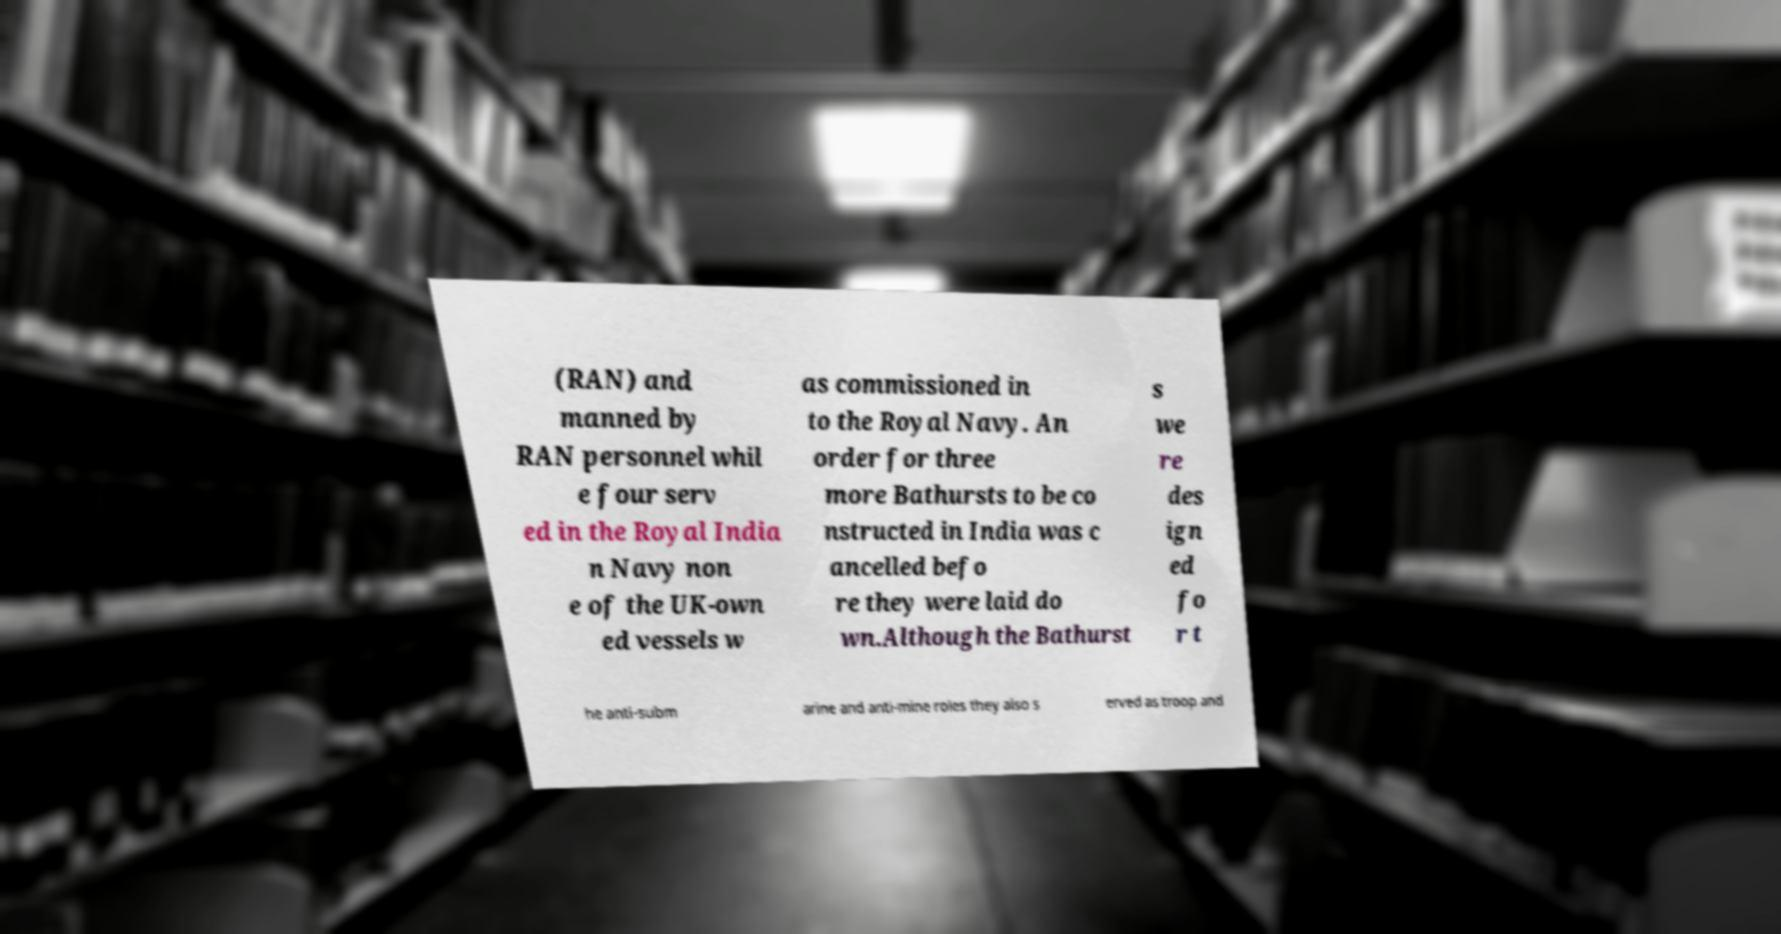Please identify and transcribe the text found in this image. (RAN) and manned by RAN personnel whil e four serv ed in the Royal India n Navy non e of the UK-own ed vessels w as commissioned in to the Royal Navy. An order for three more Bathursts to be co nstructed in India was c ancelled befo re they were laid do wn.Although the Bathurst s we re des ign ed fo r t he anti-subm arine and anti-mine roles they also s erved as troop and 